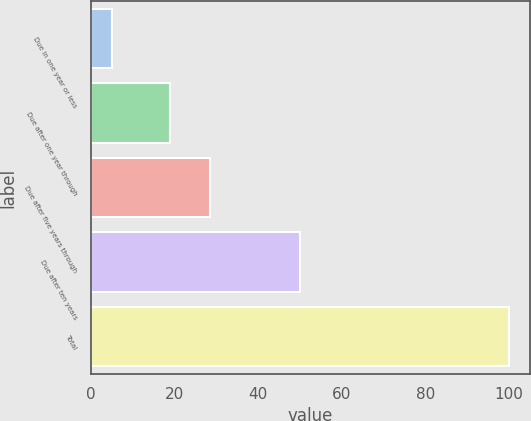Convert chart. <chart><loc_0><loc_0><loc_500><loc_500><bar_chart><fcel>Due in one year or less<fcel>Due after one year through<fcel>Due after five years through<fcel>Due after ten years<fcel>Total<nl><fcel>5<fcel>19<fcel>28.5<fcel>50<fcel>100<nl></chart> 